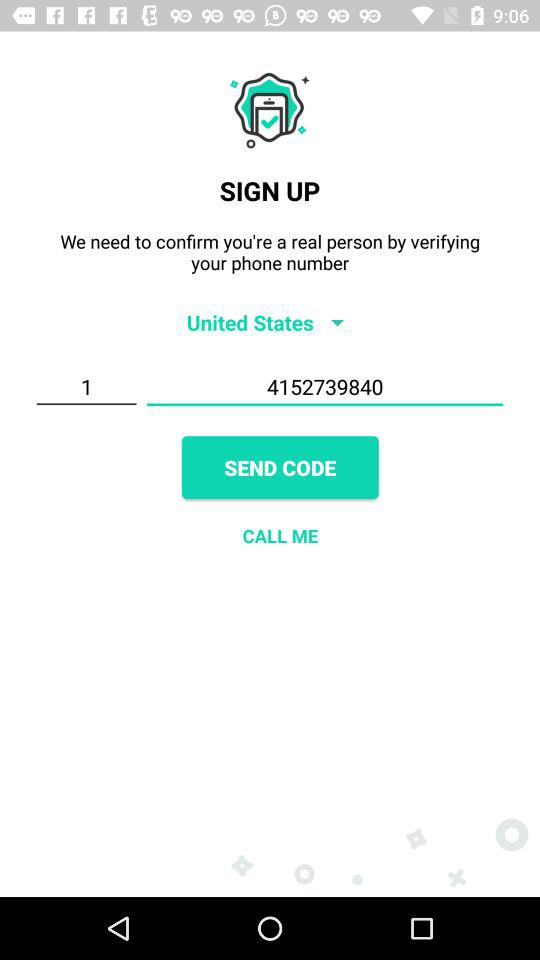Which country is selected? The selected country is the United States. 